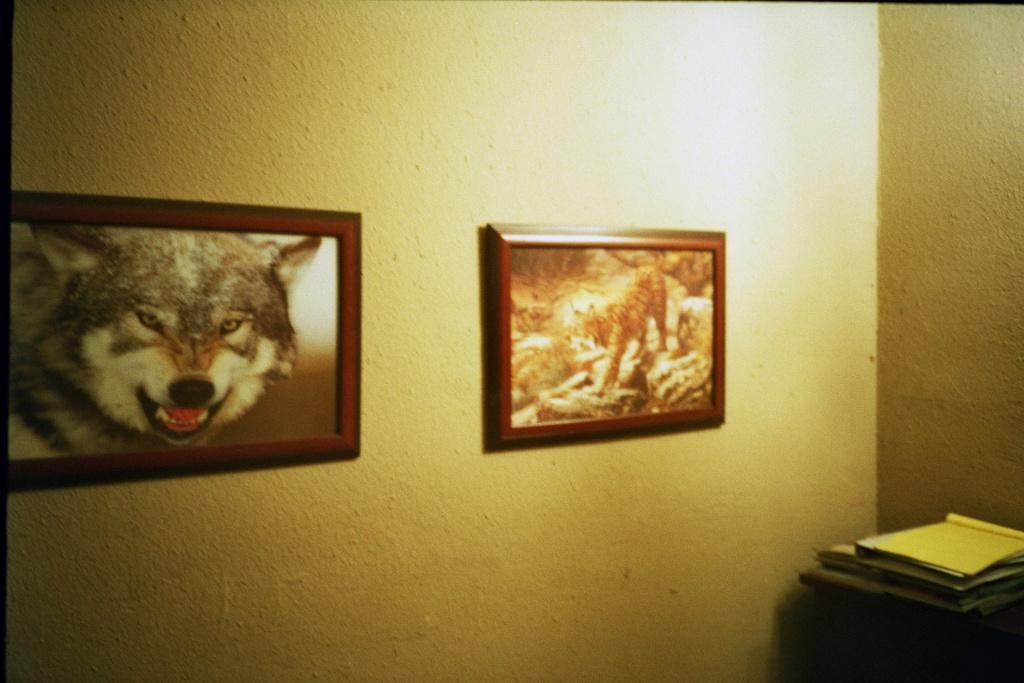What type of frames are present in the image? There are two tiger frames in the image. Where are the tiger frames attached? The tiger frames are attached to a plain wall. What can be seen in the bottom right corner of the image? There are books placed on a wooden object in the bottom right corner of the image. Can you see any bees buzzing around the tiger frames in the image? There are no bees present in the image; it only features tiger frames, a plain wall, and books on a wooden object. 